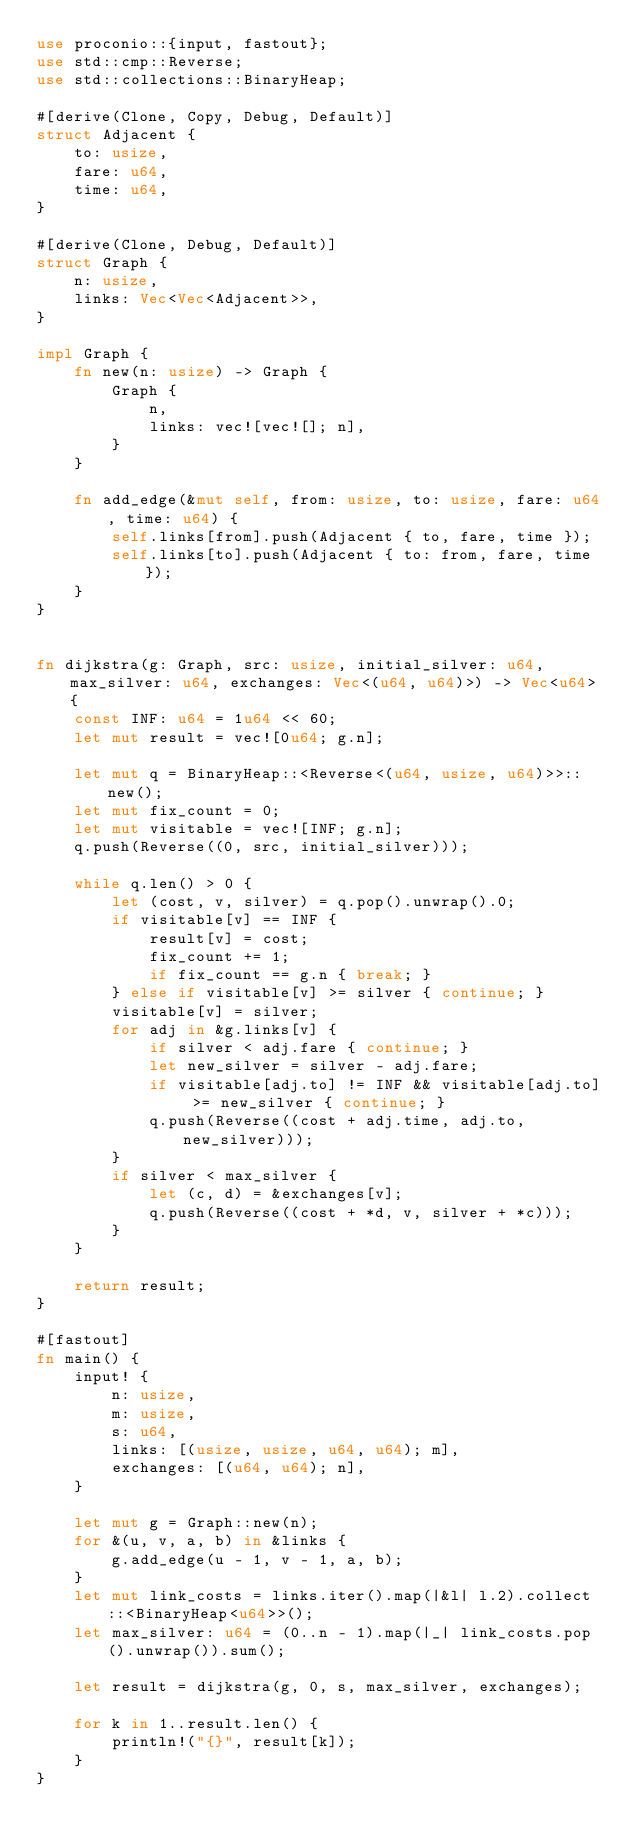Convert code to text. <code><loc_0><loc_0><loc_500><loc_500><_Rust_>use proconio::{input, fastout};
use std::cmp::Reverse;
use std::collections::BinaryHeap;

#[derive(Clone, Copy, Debug, Default)]
struct Adjacent {
    to: usize,
    fare: u64,
    time: u64,
}

#[derive(Clone, Debug, Default)]
struct Graph {
    n: usize,
    links: Vec<Vec<Adjacent>>,
}

impl Graph {
    fn new(n: usize) -> Graph {
        Graph {
            n,
            links: vec![vec![]; n],
        }
    }

    fn add_edge(&mut self, from: usize, to: usize, fare: u64, time: u64) {
        self.links[from].push(Adjacent { to, fare, time });
        self.links[to].push(Adjacent { to: from, fare, time });
    }
}


fn dijkstra(g: Graph, src: usize, initial_silver: u64, max_silver: u64, exchanges: Vec<(u64, u64)>) -> Vec<u64> {
    const INF: u64 = 1u64 << 60;
    let mut result = vec![0u64; g.n];

    let mut q = BinaryHeap::<Reverse<(u64, usize, u64)>>::new();
    let mut fix_count = 0;
    let mut visitable = vec![INF; g.n];
    q.push(Reverse((0, src, initial_silver)));

    while q.len() > 0 {
        let (cost, v, silver) = q.pop().unwrap().0;
        if visitable[v] == INF {
            result[v] = cost;
            fix_count += 1;
            if fix_count == g.n { break; }
        } else if visitable[v] >= silver { continue; }
        visitable[v] = silver;
        for adj in &g.links[v] {
            if silver < adj.fare { continue; }
            let new_silver = silver - adj.fare;
            if visitable[adj.to] != INF && visitable[adj.to] >= new_silver { continue; }
            q.push(Reverse((cost + adj.time, adj.to, new_silver)));
        }
        if silver < max_silver {
            let (c, d) = &exchanges[v];
            q.push(Reverse((cost + *d, v, silver + *c)));
        }
    }

    return result;
}

#[fastout]
fn main() {
    input! {
        n: usize,
        m: usize,
        s: u64,
        links: [(usize, usize, u64, u64); m],
        exchanges: [(u64, u64); n],
    }

    let mut g = Graph::new(n);
    for &(u, v, a, b) in &links {
        g.add_edge(u - 1, v - 1, a, b);
    }
    let mut link_costs = links.iter().map(|&l| l.2).collect::<BinaryHeap<u64>>();
    let max_silver: u64 = (0..n - 1).map(|_| link_costs.pop().unwrap()).sum();

    let result = dijkstra(g, 0, s, max_silver, exchanges);

    for k in 1..result.len() {
        println!("{}", result[k]);
    }
}
</code> 